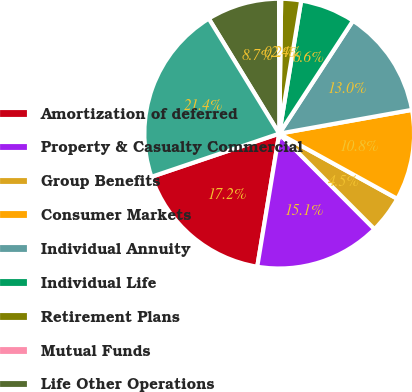Convert chart to OTSL. <chart><loc_0><loc_0><loc_500><loc_500><pie_chart><fcel>Amortization of deferred<fcel>Property & Casualty Commercial<fcel>Group Benefits<fcel>Consumer Markets<fcel>Individual Annuity<fcel>Individual Life<fcel>Retirement Plans<fcel>Mutual Funds<fcel>Life Other Operations<fcel>Total amortization of deferred<nl><fcel>17.21%<fcel>15.09%<fcel>4.49%<fcel>10.85%<fcel>12.97%<fcel>6.61%<fcel>2.37%<fcel>0.25%<fcel>8.73%<fcel>21.44%<nl></chart> 